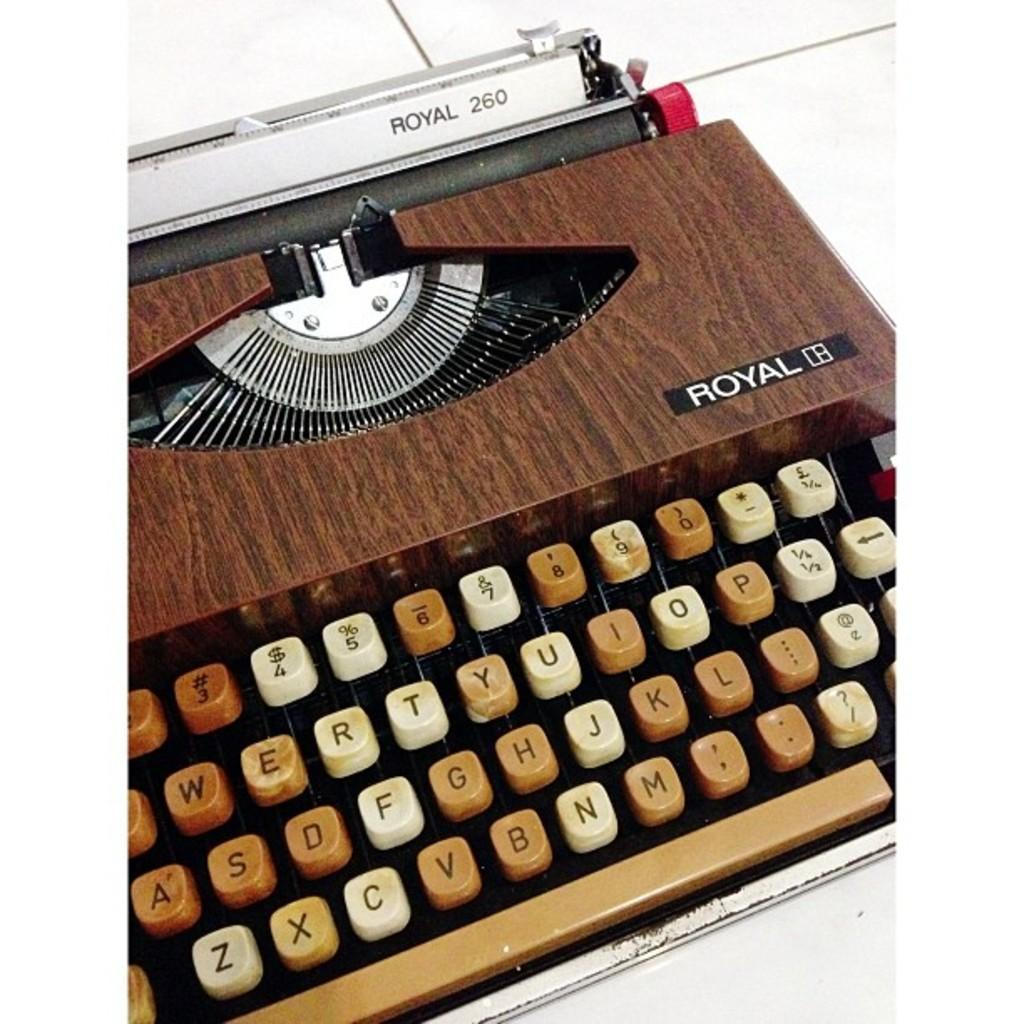<image>
Give a short and clear explanation of the subsequent image. Royal 260 brown, black, and white typewriter with letters. 